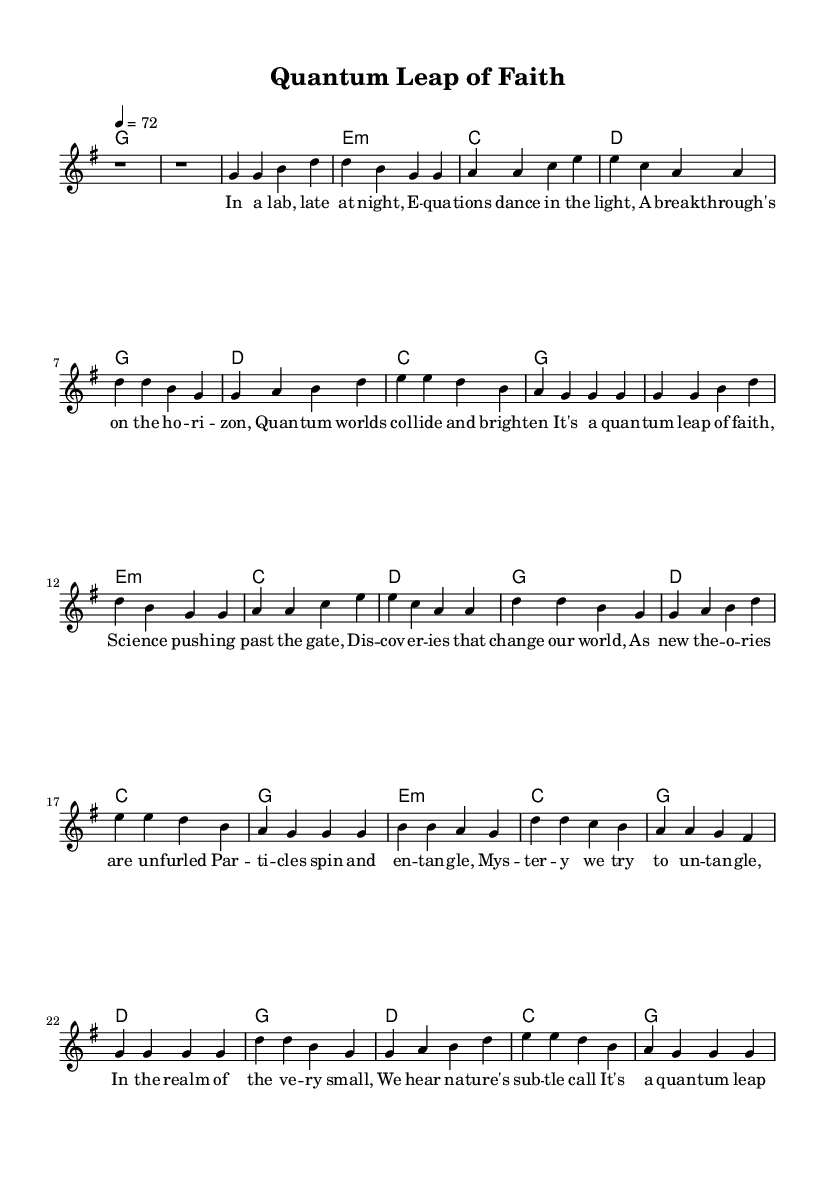What is the key signature of this music? The key signature is G major, which has one sharp (F#). This can be identified by looking at the beginning of the staff where the key signature is indicated.
Answer: G major What is the time signature of this piece? The time signature is 4/4, also known as common time. This is located at the beginning of the staff, represented as a fraction indicating four beats per measure, with a quarter note getting one beat.
Answer: 4/4 What is the tempo marking of the music? The tempo marking indicates a speed of 72 beats per minute, as found in the tempo indication in the global section. It tells you how fast the music should be played.
Answer: 72 How many verses are in this song? The song contains two verses, as indicated by the sections labeled "Verse 1" and "Verse 2" in the score.
Answer: Two What are the primary themes of the lyrics in this song? The primary themes include quantum physics and scientific discovery, as inferred from lyrics discussing particles, entanglement, and breakthroughs in science. This is derived from the content of the verses.
Answer: Science and discovery In the bridge, which prominent scientists are mentioned? The bridge references Max Planck and Albert Einstein, indicating a focus on significant figures in the realm of physics. This can be directly taken from the lyrics in the bridge section.
Answer: Planck and Einstein What chord progression is used in the chorus? The chord progression used in the chorus is G, D, C, G, as seen in the "Chorus" section of the harmonies. This progression is typical in country rock music, utilizing standard major chords.
Answer: G, D, C, G 